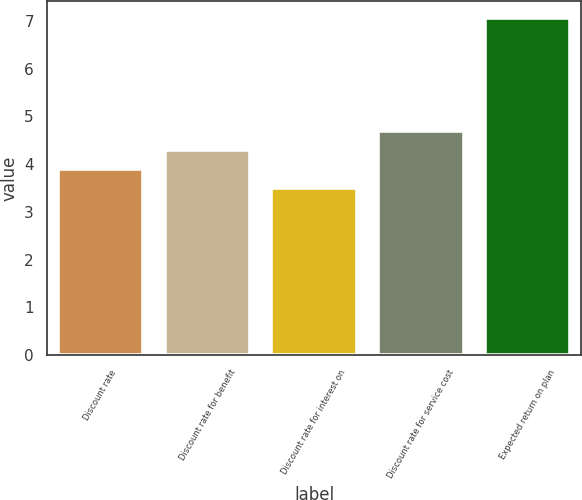<chart> <loc_0><loc_0><loc_500><loc_500><bar_chart><fcel>Discount rate<fcel>Discount rate for benefit<fcel>Discount rate for interest on<fcel>Discount rate for service cost<fcel>Expected return on plan<nl><fcel>3.89<fcel>4.29<fcel>3.49<fcel>4.69<fcel>7.07<nl></chart> 